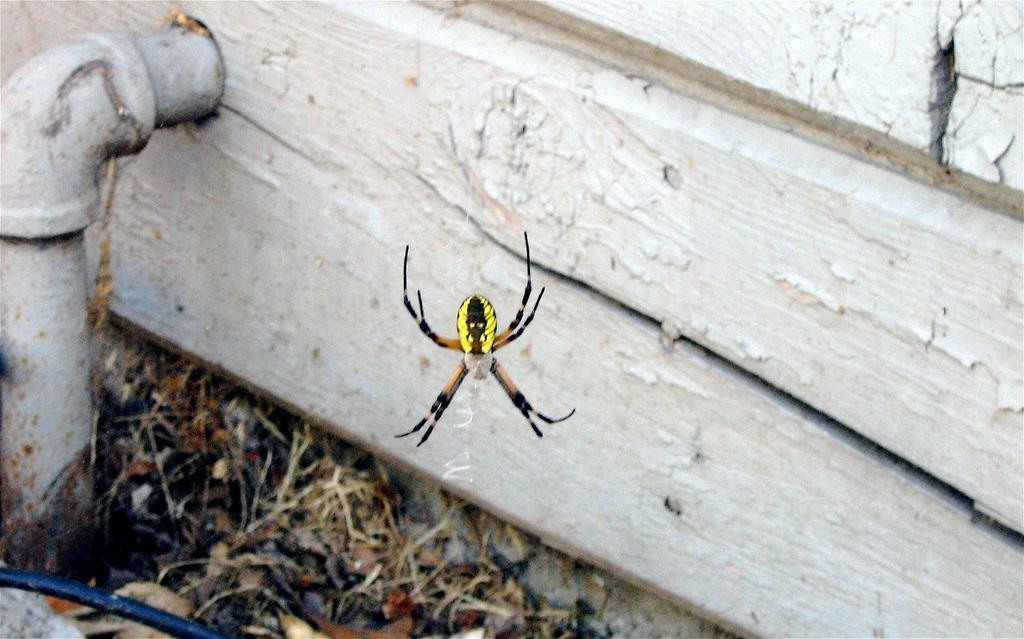Describe this image in one or two sentences. In this picture we can see a spider in the middle, at the bottom there are some leaves, on the left side we can see a pipe, on the right side there is wood. 